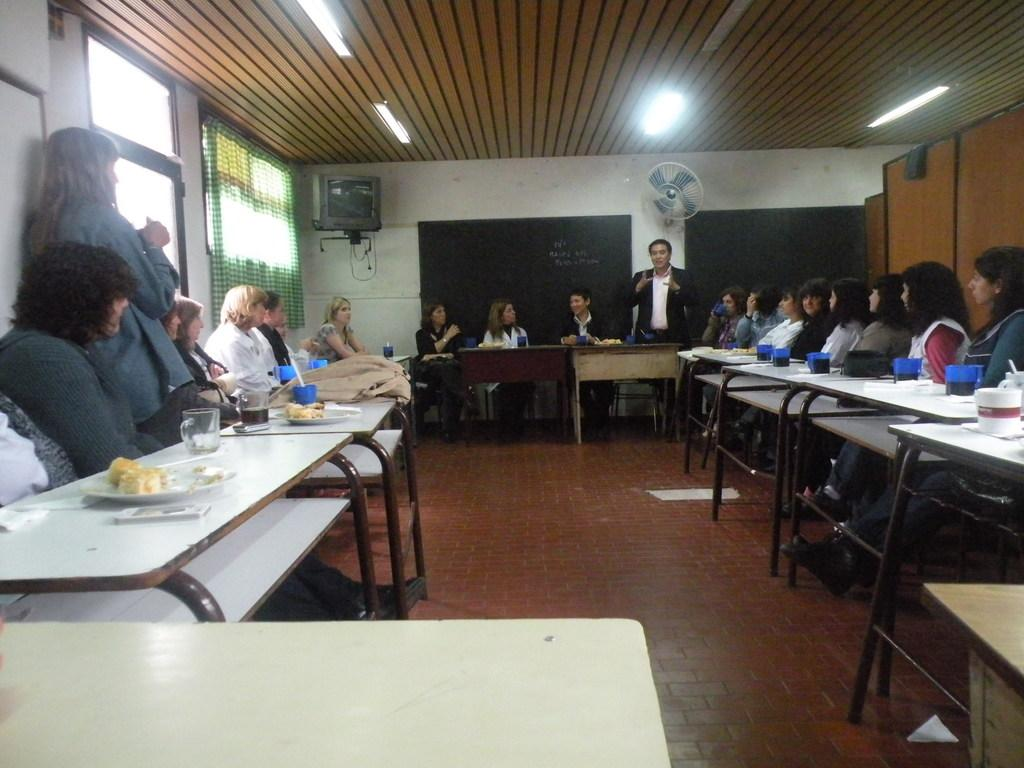What are the people in the image doing? There is a group of people sitting in the image, which suggests they are engaged in an activity or gathering. Is there anyone standing in the image? Yes, there is a person standing in the image. What are the tables in front of the people used for? The tables have food served on plates, which indicates that they are being used for dining or serving food. What type of beverage container is present in the image? Coffee mugs are present in the image. What type of patch can be seen on the person's clothing in the image? There is no patch visible on anyone's clothing in the image. 